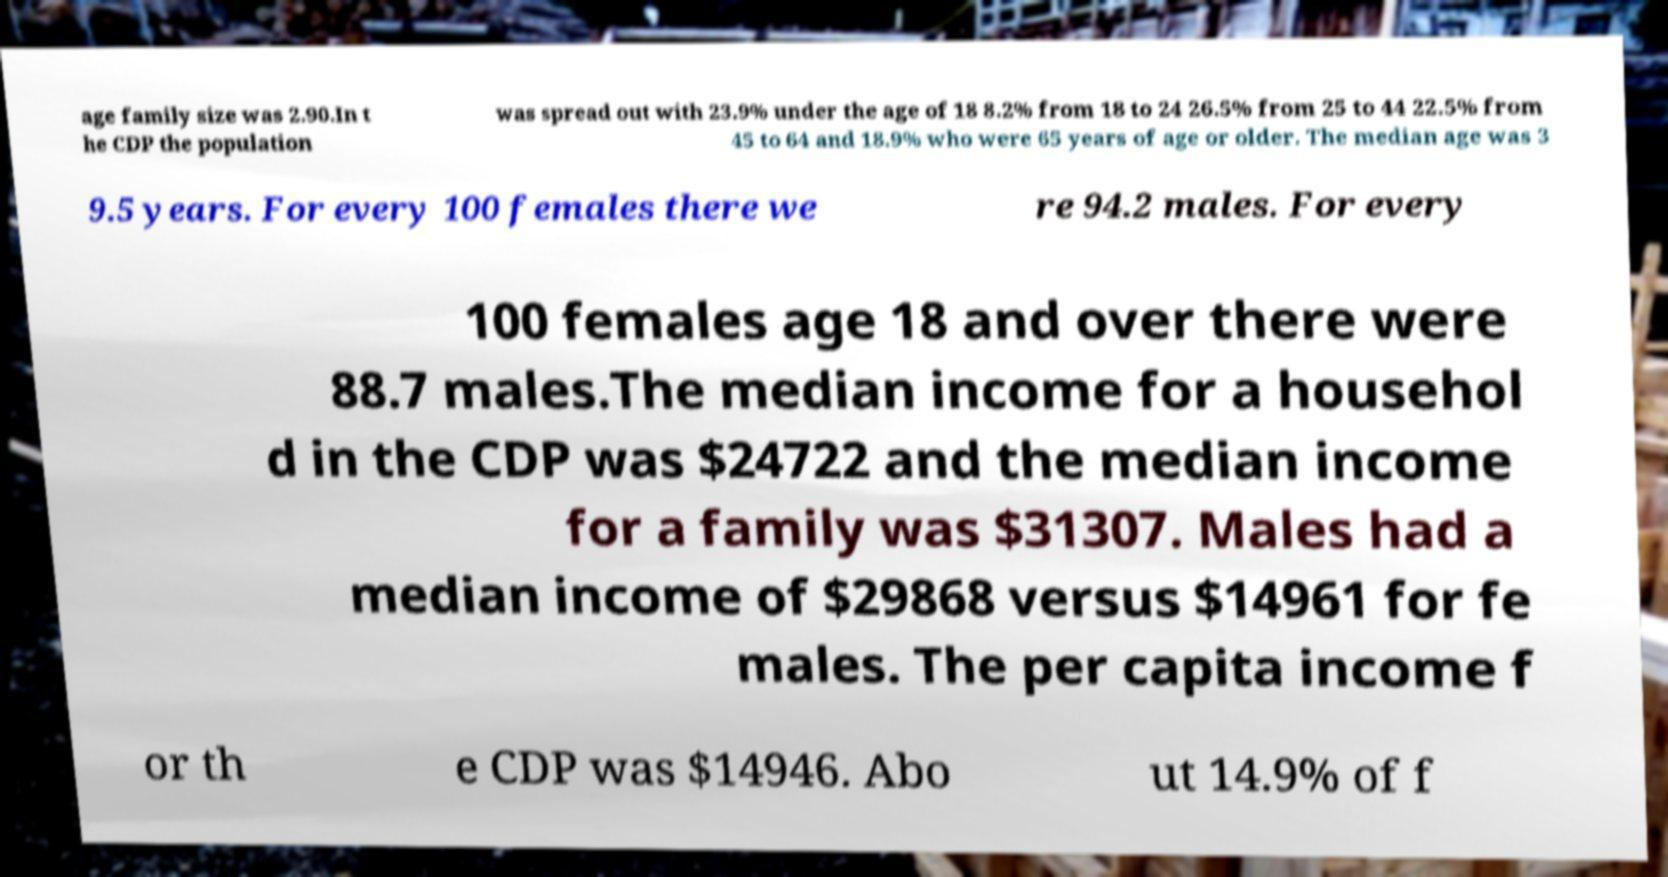Could you extract and type out the text from this image? age family size was 2.90.In t he CDP the population was spread out with 23.9% under the age of 18 8.2% from 18 to 24 26.5% from 25 to 44 22.5% from 45 to 64 and 18.9% who were 65 years of age or older. The median age was 3 9.5 years. For every 100 females there we re 94.2 males. For every 100 females age 18 and over there were 88.7 males.The median income for a househol d in the CDP was $24722 and the median income for a family was $31307. Males had a median income of $29868 versus $14961 for fe males. The per capita income f or th e CDP was $14946. Abo ut 14.9% of f 